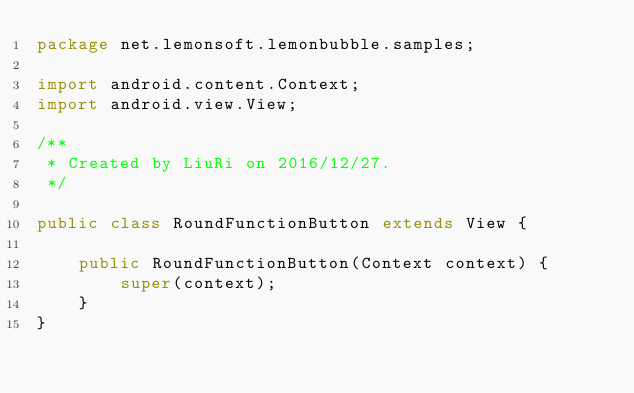<code> <loc_0><loc_0><loc_500><loc_500><_Java_>package net.lemonsoft.lemonbubble.samples;

import android.content.Context;
import android.view.View;

/**
 * Created by LiuRi on 2016/12/27.
 */

public class RoundFunctionButton extends View {

    public RoundFunctionButton(Context context) {
        super(context);
    }
}
</code> 